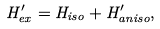<formula> <loc_0><loc_0><loc_500><loc_500>H _ { e x } ^ { \prime } = H _ { i s o } + H _ { a n i s o } ^ { \prime } ,</formula> 